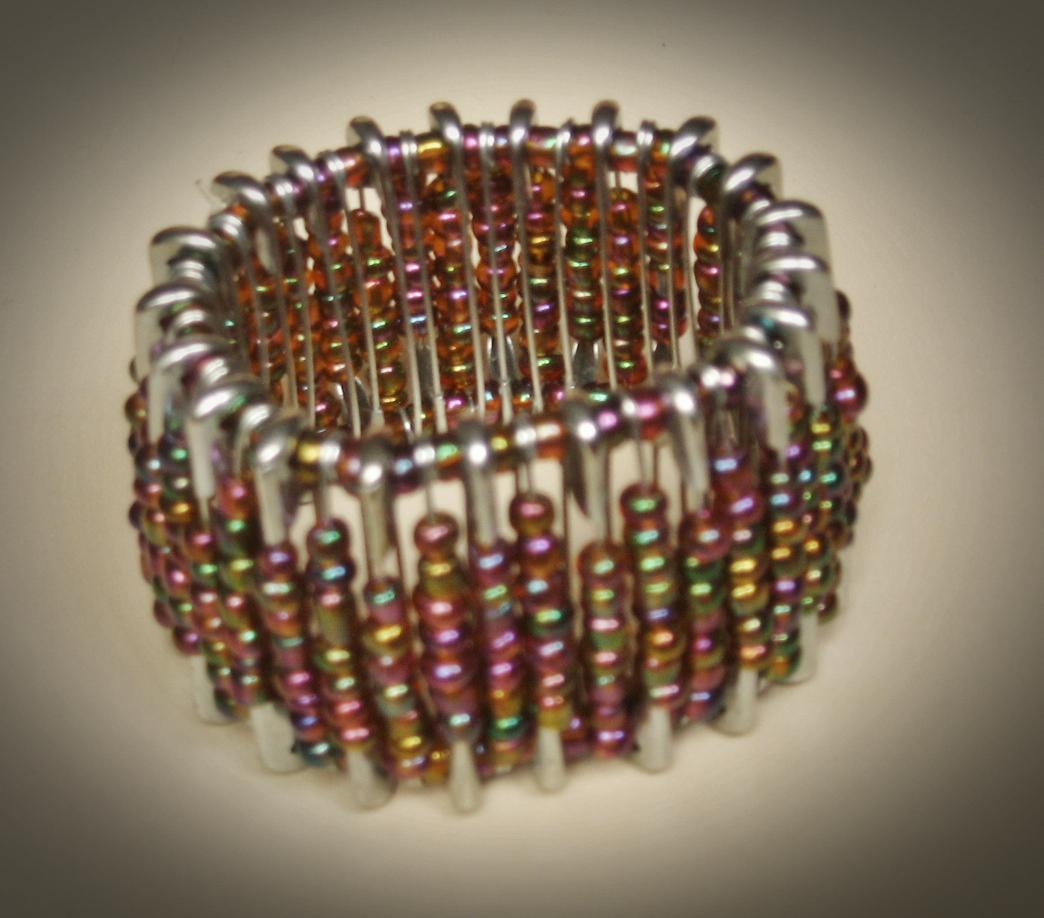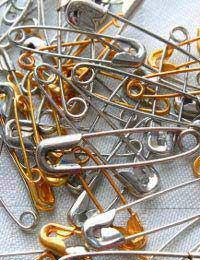The first image is the image on the left, the second image is the image on the right. Given the left and right images, does the statement "At least one image in the pari has both gold and silver colored safety pins." hold true? Answer yes or no. Yes. The first image is the image on the left, the second image is the image on the right. Considering the images on both sides, is "In one picture the safety pins are in a pile on top of each other." valid? Answer yes or no. Yes. 